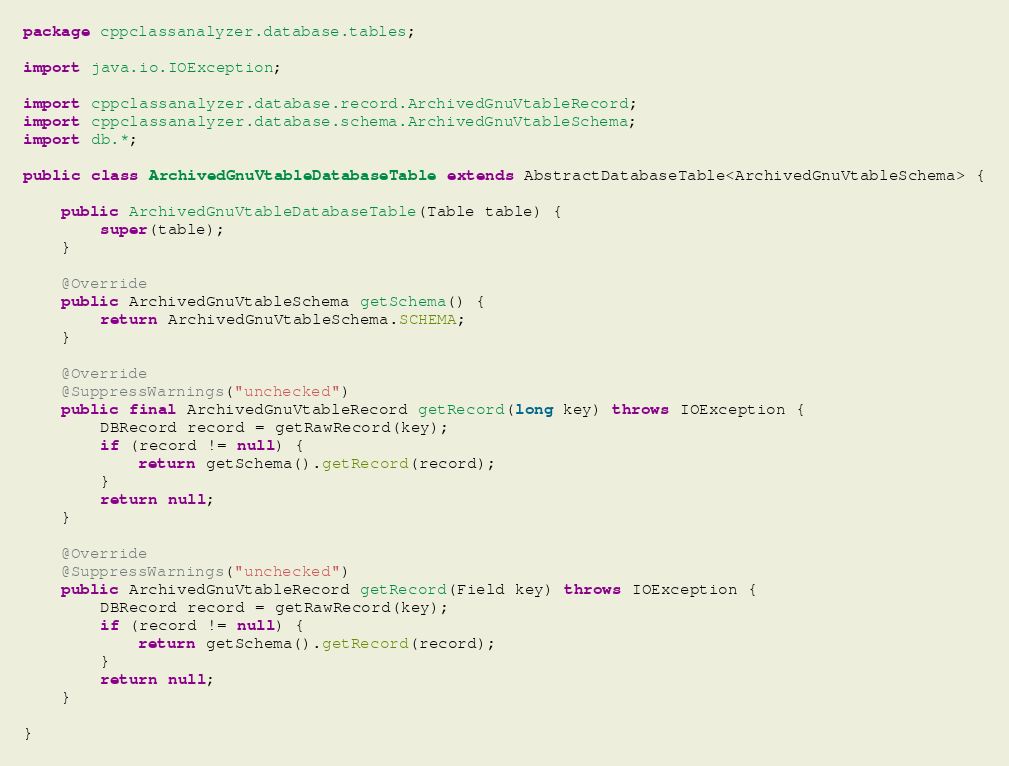Convert code to text. <code><loc_0><loc_0><loc_500><loc_500><_Java_>package cppclassanalyzer.database.tables;

import java.io.IOException;

import cppclassanalyzer.database.record.ArchivedGnuVtableRecord;
import cppclassanalyzer.database.schema.ArchivedGnuVtableSchema;
import db.*;

public class ArchivedGnuVtableDatabaseTable extends AbstractDatabaseTable<ArchivedGnuVtableSchema> {

	public ArchivedGnuVtableDatabaseTable(Table table) {
		super(table);
	}

	@Override
	public ArchivedGnuVtableSchema getSchema() {
		return ArchivedGnuVtableSchema.SCHEMA;
	}

	@Override
	@SuppressWarnings("unchecked")
	public final ArchivedGnuVtableRecord getRecord(long key) throws IOException {
		DBRecord record = getRawRecord(key);
		if (record != null) {
			return getSchema().getRecord(record);
		}
		return null;
	}

	@Override
	@SuppressWarnings("unchecked")
	public ArchivedGnuVtableRecord getRecord(Field key) throws IOException {
		DBRecord record = getRawRecord(key);
		if (record != null) {
			return getSchema().getRecord(record);
		}
		return null;
	}

}
</code> 